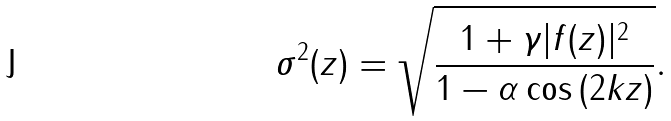<formula> <loc_0><loc_0><loc_500><loc_500>\sigma ^ { 2 } ( z ) = \sqrt { { \frac { 1 + \gamma | f ( z ) | ^ { 2 } } { 1 - \alpha \cos { ( 2 k z ) } } } } .</formula> 